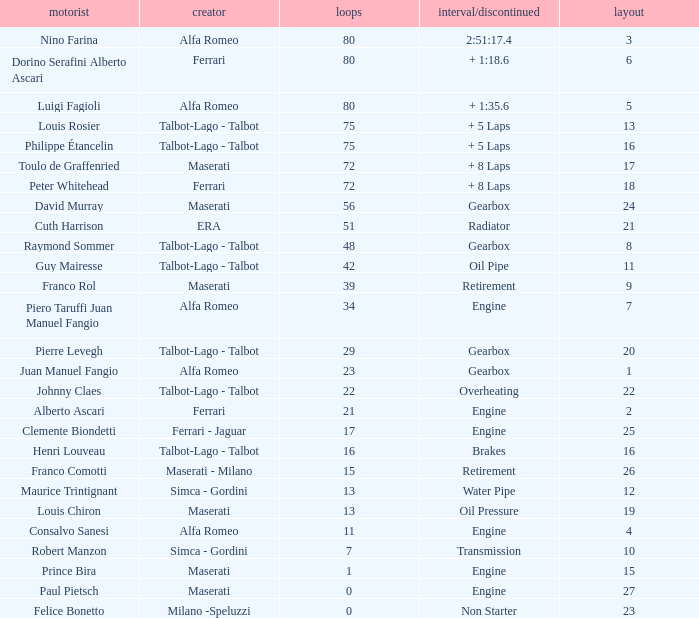What was the smallest grid for Prince bira? 15.0. 